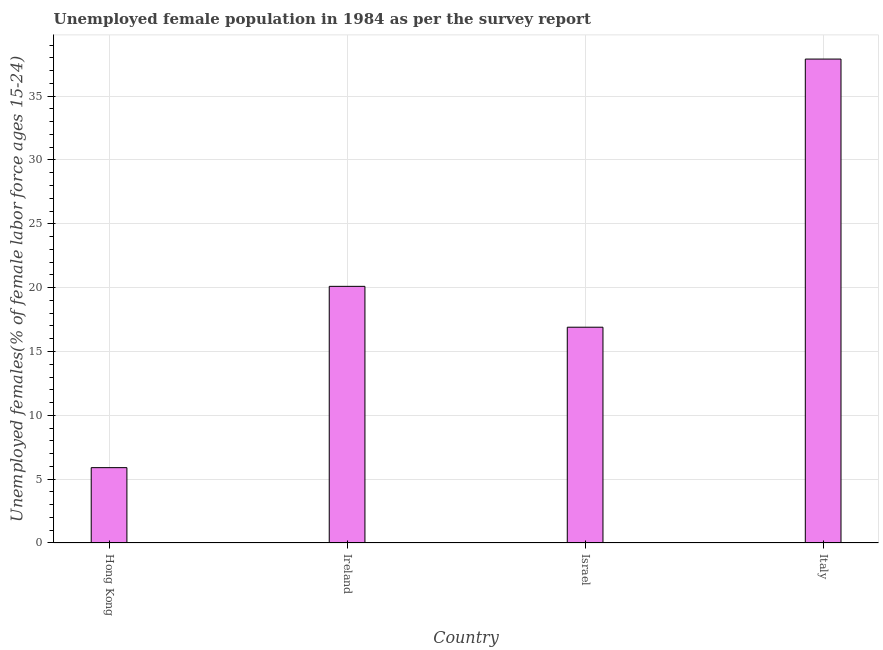Does the graph contain any zero values?
Offer a very short reply. No. What is the title of the graph?
Your answer should be compact. Unemployed female population in 1984 as per the survey report. What is the label or title of the X-axis?
Ensure brevity in your answer.  Country. What is the label or title of the Y-axis?
Give a very brief answer. Unemployed females(% of female labor force ages 15-24). What is the unemployed female youth in Ireland?
Ensure brevity in your answer.  20.1. Across all countries, what is the maximum unemployed female youth?
Keep it short and to the point. 37.9. Across all countries, what is the minimum unemployed female youth?
Your answer should be compact. 5.9. In which country was the unemployed female youth minimum?
Offer a very short reply. Hong Kong. What is the sum of the unemployed female youth?
Your answer should be compact. 80.8. What is the difference between the unemployed female youth in Hong Kong and Israel?
Ensure brevity in your answer.  -11. What is the average unemployed female youth per country?
Keep it short and to the point. 20.2. What is the median unemployed female youth?
Provide a short and direct response. 18.5. In how many countries, is the unemployed female youth greater than 11 %?
Give a very brief answer. 3. What is the ratio of the unemployed female youth in Israel to that in Italy?
Offer a terse response. 0.45. Is the unemployed female youth in Hong Kong less than that in Israel?
Your answer should be very brief. Yes. Is the difference between the unemployed female youth in Ireland and Israel greater than the difference between any two countries?
Keep it short and to the point. No. What is the difference between the highest and the second highest unemployed female youth?
Provide a short and direct response. 17.8. What is the difference between the highest and the lowest unemployed female youth?
Your answer should be very brief. 32. In how many countries, is the unemployed female youth greater than the average unemployed female youth taken over all countries?
Offer a terse response. 1. Are all the bars in the graph horizontal?
Make the answer very short. No. How many countries are there in the graph?
Give a very brief answer. 4. What is the difference between two consecutive major ticks on the Y-axis?
Ensure brevity in your answer.  5. Are the values on the major ticks of Y-axis written in scientific E-notation?
Make the answer very short. No. What is the Unemployed females(% of female labor force ages 15-24) in Hong Kong?
Your response must be concise. 5.9. What is the Unemployed females(% of female labor force ages 15-24) of Ireland?
Make the answer very short. 20.1. What is the Unemployed females(% of female labor force ages 15-24) of Israel?
Your answer should be very brief. 16.9. What is the Unemployed females(% of female labor force ages 15-24) in Italy?
Your answer should be compact. 37.9. What is the difference between the Unemployed females(% of female labor force ages 15-24) in Hong Kong and Italy?
Keep it short and to the point. -32. What is the difference between the Unemployed females(% of female labor force ages 15-24) in Ireland and Israel?
Keep it short and to the point. 3.2. What is the difference between the Unemployed females(% of female labor force ages 15-24) in Ireland and Italy?
Your answer should be compact. -17.8. What is the difference between the Unemployed females(% of female labor force ages 15-24) in Israel and Italy?
Offer a terse response. -21. What is the ratio of the Unemployed females(% of female labor force ages 15-24) in Hong Kong to that in Ireland?
Provide a short and direct response. 0.29. What is the ratio of the Unemployed females(% of female labor force ages 15-24) in Hong Kong to that in Israel?
Offer a very short reply. 0.35. What is the ratio of the Unemployed females(% of female labor force ages 15-24) in Hong Kong to that in Italy?
Your response must be concise. 0.16. What is the ratio of the Unemployed females(% of female labor force ages 15-24) in Ireland to that in Israel?
Ensure brevity in your answer.  1.19. What is the ratio of the Unemployed females(% of female labor force ages 15-24) in Ireland to that in Italy?
Your response must be concise. 0.53. What is the ratio of the Unemployed females(% of female labor force ages 15-24) in Israel to that in Italy?
Keep it short and to the point. 0.45. 